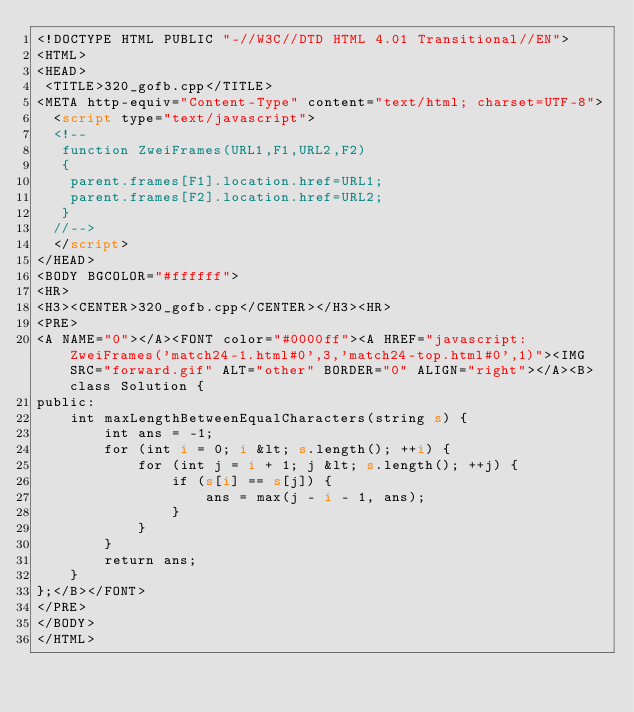Convert code to text. <code><loc_0><loc_0><loc_500><loc_500><_HTML_><!DOCTYPE HTML PUBLIC "-//W3C//DTD HTML 4.01 Transitional//EN">
<HTML>
<HEAD>
 <TITLE>320_gofb.cpp</TITLE>
<META http-equiv="Content-Type" content="text/html; charset=UTF-8">
  <script type="text/javascript">
  <!--
   function ZweiFrames(URL1,F1,URL2,F2)
   {
    parent.frames[F1].location.href=URL1;
    parent.frames[F2].location.href=URL2;
   }
  //-->
  </script>
</HEAD>
<BODY BGCOLOR="#ffffff">
<HR>
<H3><CENTER>320_gofb.cpp</CENTER></H3><HR>
<PRE>
<A NAME="0"></A><FONT color="#0000ff"><A HREF="javascript:ZweiFrames('match24-1.html#0',3,'match24-top.html#0',1)"><IMG SRC="forward.gif" ALT="other" BORDER="0" ALIGN="right"></A><B>class Solution {
public:
    int maxLengthBetweenEqualCharacters(string s) {
        int ans = -1;
        for (int i = 0; i &lt; s.length(); ++i) {
            for (int j = i + 1; j &lt; s.length(); ++j) {
                if (s[i] == s[j]) {
                    ans = max(j - i - 1, ans);
                }
            }
        }
        return ans;
    }
};</B></FONT>
</PRE>
</BODY>
</HTML>
</code> 